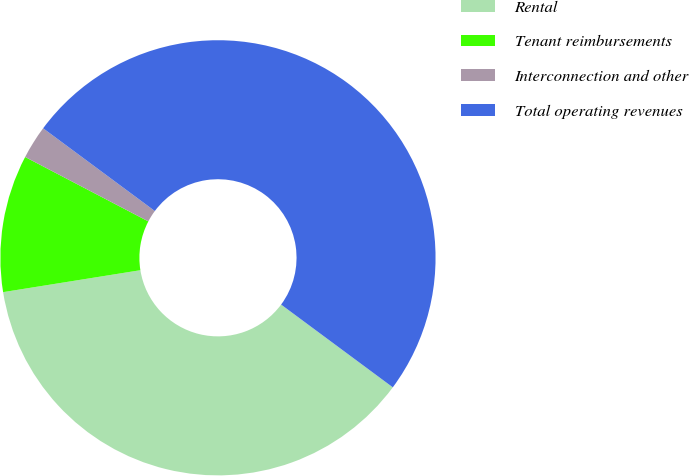<chart> <loc_0><loc_0><loc_500><loc_500><pie_chart><fcel>Rental<fcel>Tenant reimbursements<fcel>Interconnection and other<fcel>Total operating revenues<nl><fcel>37.33%<fcel>10.19%<fcel>2.48%<fcel>50.0%<nl></chart> 